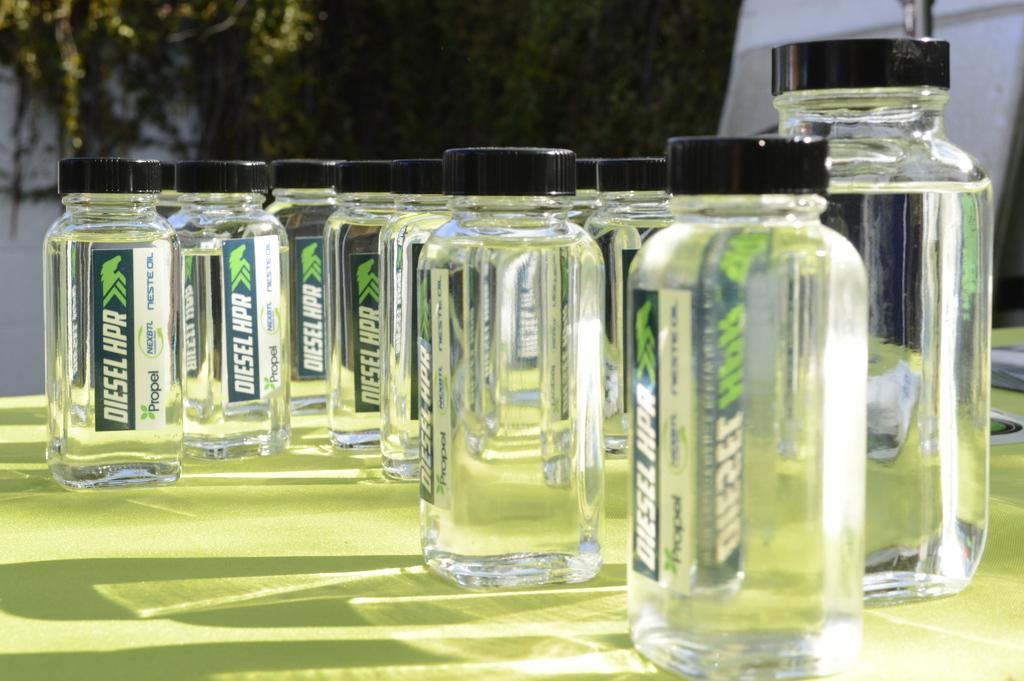What type of containers are visible in the image? There are glass bottles with caps in the image. Where are the glass bottles located? The glass bottles are placed on a table. What can be seen in the background of the image? There are trees and a wall in the background of the image. How many snakes are slithering on the table in the image? There are no snakes present in the image; the table only has glass bottles with caps. 